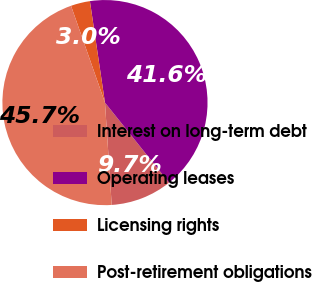Convert chart to OTSL. <chart><loc_0><loc_0><loc_500><loc_500><pie_chart><fcel>Interest on long-term debt<fcel>Operating leases<fcel>Licensing rights<fcel>Post-retirement obligations<nl><fcel>9.69%<fcel>41.61%<fcel>3.02%<fcel>45.68%<nl></chart> 